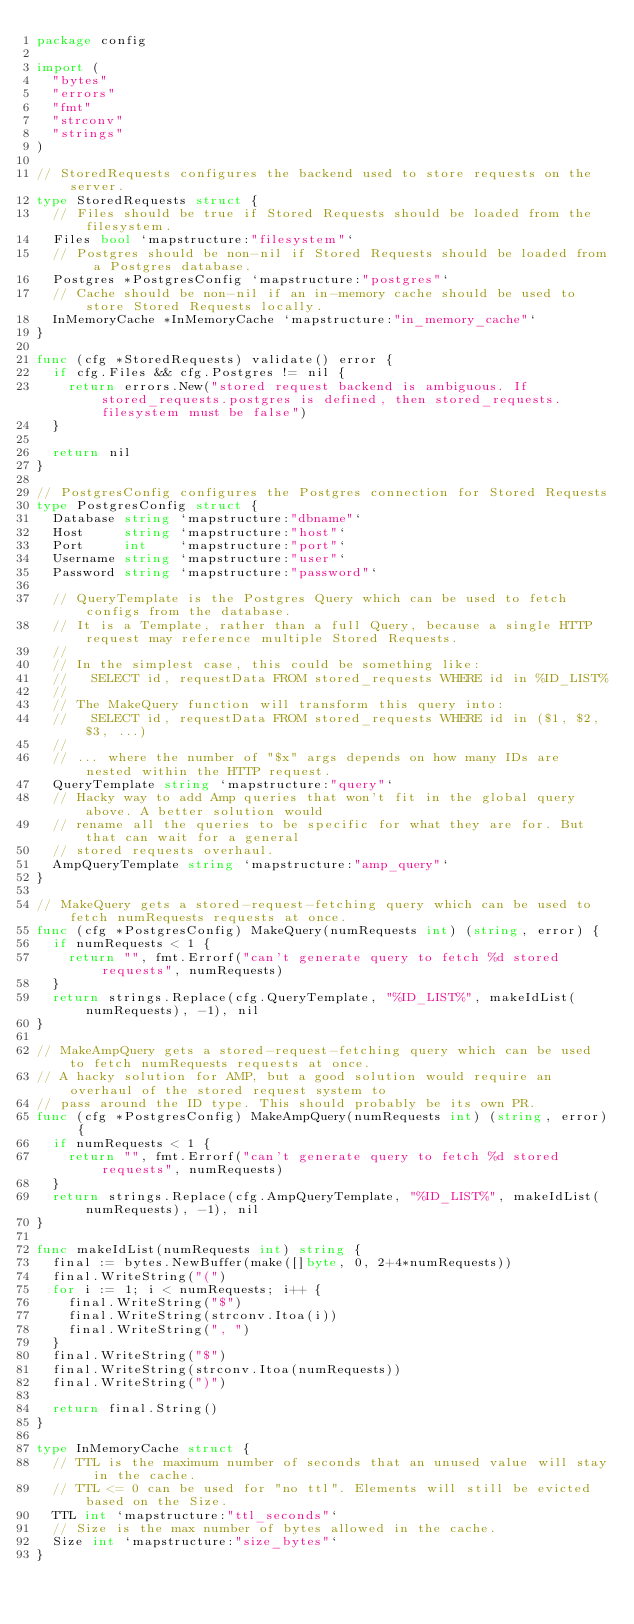Convert code to text. <code><loc_0><loc_0><loc_500><loc_500><_Go_>package config

import (
	"bytes"
	"errors"
	"fmt"
	"strconv"
	"strings"
)

// StoredRequests configures the backend used to store requests on the server.
type StoredRequests struct {
	// Files should be true if Stored Requests should be loaded from the filesystem.
	Files bool `mapstructure:"filesystem"`
	// Postgres should be non-nil if Stored Requests should be loaded from a Postgres database.
	Postgres *PostgresConfig `mapstructure:"postgres"`
	// Cache should be non-nil if an in-memory cache should be used to store Stored Requests locally.
	InMemoryCache *InMemoryCache `mapstructure:"in_memory_cache"`
}

func (cfg *StoredRequests) validate() error {
	if cfg.Files && cfg.Postgres != nil {
		return errors.New("stored request backend is ambiguous. If stored_requests.postgres is defined, then stored_requests.filesystem must be false")
	}

	return nil
}

// PostgresConfig configures the Postgres connection for Stored Requests
type PostgresConfig struct {
	Database string `mapstructure:"dbname"`
	Host     string `mapstructure:"host"`
	Port     int    `mapstructure:"port"`
	Username string `mapstructure:"user"`
	Password string `mapstructure:"password"`

	// QueryTemplate is the Postgres Query which can be used to fetch configs from the database.
	// It is a Template, rather than a full Query, because a single HTTP request may reference multiple Stored Requests.
	//
	// In the simplest case, this could be something like:
	//   SELECT id, requestData FROM stored_requests WHERE id in %ID_LIST%
	//
	// The MakeQuery function will transform this query into:
	//   SELECT id, requestData FROM stored_requests WHERE id in ($1, $2, $3, ...)
	//
	// ... where the number of "$x" args depends on how many IDs are nested within the HTTP request.
	QueryTemplate string `mapstructure:"query"`
	// Hacky way to add Amp queries that won't fit in the global query above. A better solution would
	// rename all the queries to be specific for what they are for. But that can wait for a general
	// stored requests overhaul.
	AmpQueryTemplate string `mapstructure:"amp_query"`
}

// MakeQuery gets a stored-request-fetching query which can be used to fetch numRequests requests at once.
func (cfg *PostgresConfig) MakeQuery(numRequests int) (string, error) {
	if numRequests < 1 {
		return "", fmt.Errorf("can't generate query to fetch %d stored requests", numRequests)
	}
	return strings.Replace(cfg.QueryTemplate, "%ID_LIST%", makeIdList(numRequests), -1), nil
}

// MakeAmpQuery gets a stored-request-fetching query which can be used to fetch numRequests requests at once.
// A hacky solution for AMP, but a good solution would require an overhaul of the stored request system to
// pass around the ID type. This should probably be its own PR.
func (cfg *PostgresConfig) MakeAmpQuery(numRequests int) (string, error) {
	if numRequests < 1 {
		return "", fmt.Errorf("can't generate query to fetch %d stored requests", numRequests)
	}
	return strings.Replace(cfg.AmpQueryTemplate, "%ID_LIST%", makeIdList(numRequests), -1), nil
}

func makeIdList(numRequests int) string {
	final := bytes.NewBuffer(make([]byte, 0, 2+4*numRequests))
	final.WriteString("(")
	for i := 1; i < numRequests; i++ {
		final.WriteString("$")
		final.WriteString(strconv.Itoa(i))
		final.WriteString(", ")
	}
	final.WriteString("$")
	final.WriteString(strconv.Itoa(numRequests))
	final.WriteString(")")

	return final.String()
}

type InMemoryCache struct {
	// TTL is the maximum number of seconds that an unused value will stay in the cache.
	// TTL <= 0 can be used for "no ttl". Elements will still be evicted based on the Size.
	TTL int `mapstructure:"ttl_seconds"`
	// Size is the max number of bytes allowed in the cache.
	Size int `mapstructure:"size_bytes"`
}
</code> 